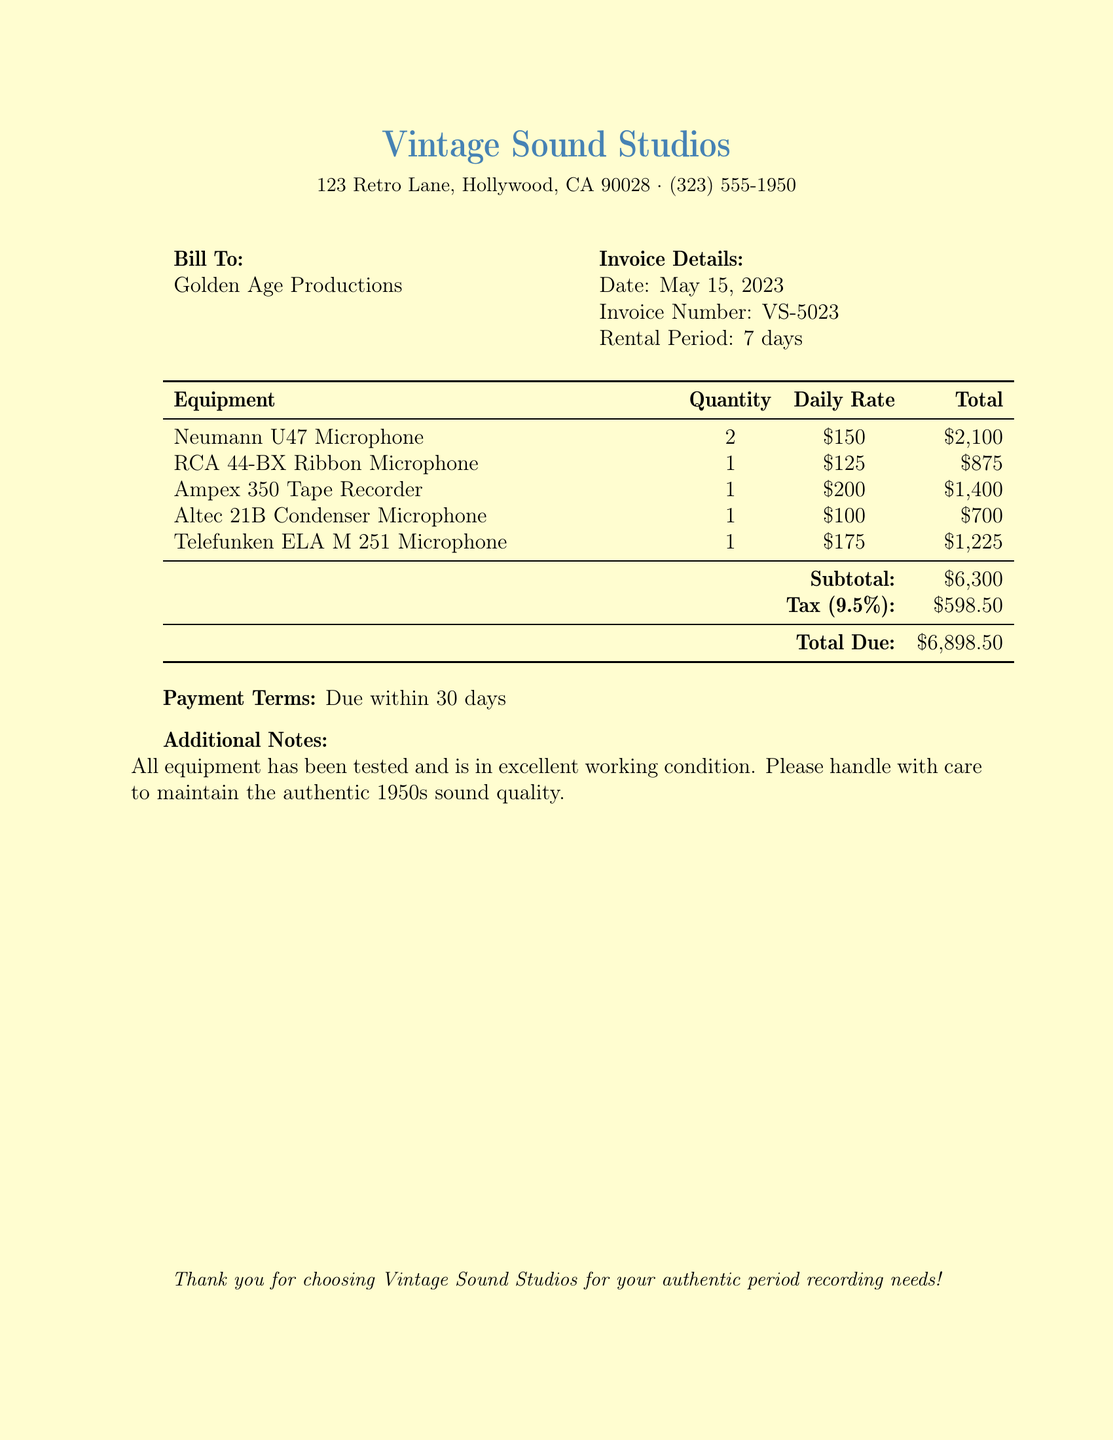What is the invoice number? The invoice number is specified in the document under Invoice Details.
Answer: VS-5023 What is the rental period? The rental period is stated in the document under Invoice Details.
Answer: 7 days How much is the daily rate for the Neumann U47 Microphone? The daily rate for the Neumann U47 Microphone can be found in the equipment table.
Answer: $150 Who is the bill addressed to? The bill is addressed to the company specified under Bill To.
Answer: Golden Age Productions What is the tax percentage applied to the subtotal? The tax percentage is mentioned in the document in the tax section.
Answer: 9.5% What is the total due amount? The total due amount is stated at the bottom of the billing table.
Answer: $6,898.50 How many RCA 44-BX Ribbon Microphones are rented? The quantity of RCA 44-BX Ribbon Microphones is shown in the equipment table.
Answer: 1 What address is Vintage Sound Studios located at? The address is found at the top of the document under the studio name.
Answer: 123 Retro Lane, Hollywood, CA 90028 What are the payment terms? The payment terms are specified at the bottom of the document.
Answer: Due within 30 days 